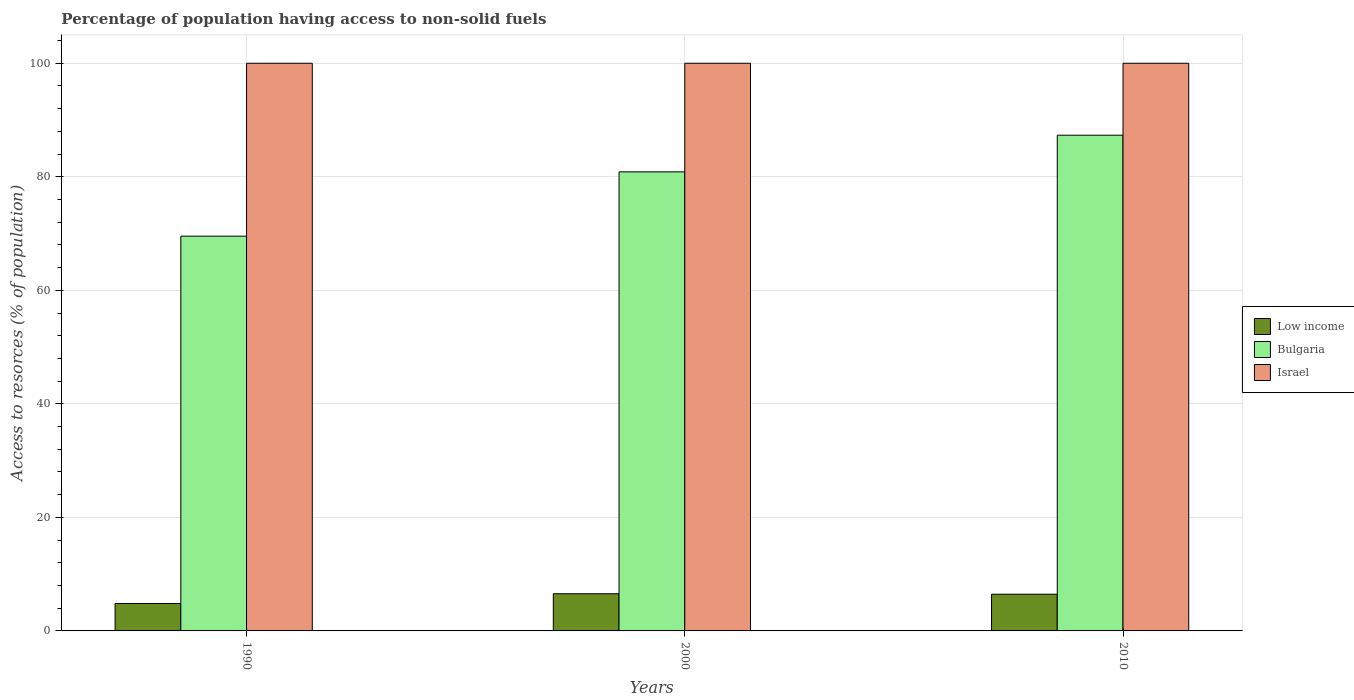How many bars are there on the 2nd tick from the left?
Offer a very short reply. 3. In how many cases, is the number of bars for a given year not equal to the number of legend labels?
Ensure brevity in your answer.  0. What is the percentage of population having access to non-solid fuels in Bulgaria in 2010?
Your answer should be compact. 87.33. Across all years, what is the maximum percentage of population having access to non-solid fuels in Bulgaria?
Provide a short and direct response. 87.33. Across all years, what is the minimum percentage of population having access to non-solid fuels in Bulgaria?
Your answer should be very brief. 69.54. In which year was the percentage of population having access to non-solid fuels in Israel maximum?
Offer a very short reply. 1990. What is the total percentage of population having access to non-solid fuels in Low income in the graph?
Make the answer very short. 17.84. What is the difference between the percentage of population having access to non-solid fuels in Bulgaria in 2000 and that in 2010?
Your answer should be compact. -6.46. What is the difference between the percentage of population having access to non-solid fuels in Israel in 2000 and the percentage of population having access to non-solid fuels in Bulgaria in 1990?
Provide a short and direct response. 30.46. What is the average percentage of population having access to non-solid fuels in Low income per year?
Offer a terse response. 5.95. In the year 2000, what is the difference between the percentage of population having access to non-solid fuels in Israel and percentage of population having access to non-solid fuels in Bulgaria?
Make the answer very short. 19.13. What is the ratio of the percentage of population having access to non-solid fuels in Low income in 1990 to that in 2010?
Offer a very short reply. 0.75. Is the difference between the percentage of population having access to non-solid fuels in Israel in 1990 and 2010 greater than the difference between the percentage of population having access to non-solid fuels in Bulgaria in 1990 and 2010?
Offer a very short reply. Yes. What is the difference between the highest and the second highest percentage of population having access to non-solid fuels in Low income?
Give a very brief answer. 0.09. In how many years, is the percentage of population having access to non-solid fuels in Low income greater than the average percentage of population having access to non-solid fuels in Low income taken over all years?
Ensure brevity in your answer.  2. Is the sum of the percentage of population having access to non-solid fuels in Low income in 1990 and 2000 greater than the maximum percentage of population having access to non-solid fuels in Bulgaria across all years?
Offer a terse response. No. How many bars are there?
Keep it short and to the point. 9. Are all the bars in the graph horizontal?
Offer a terse response. No. How many years are there in the graph?
Provide a short and direct response. 3. Does the graph contain grids?
Give a very brief answer. Yes. How many legend labels are there?
Provide a short and direct response. 3. What is the title of the graph?
Your answer should be compact. Percentage of population having access to non-solid fuels. What is the label or title of the Y-axis?
Your answer should be very brief. Access to resorces (% of population). What is the Access to resorces (% of population) in Low income in 1990?
Ensure brevity in your answer.  4.83. What is the Access to resorces (% of population) of Bulgaria in 1990?
Your answer should be very brief. 69.54. What is the Access to resorces (% of population) in Low income in 2000?
Your answer should be very brief. 6.55. What is the Access to resorces (% of population) in Bulgaria in 2000?
Provide a short and direct response. 80.87. What is the Access to resorces (% of population) of Low income in 2010?
Your answer should be very brief. 6.46. What is the Access to resorces (% of population) of Bulgaria in 2010?
Provide a succinct answer. 87.33. Across all years, what is the maximum Access to resorces (% of population) of Low income?
Keep it short and to the point. 6.55. Across all years, what is the maximum Access to resorces (% of population) of Bulgaria?
Offer a very short reply. 87.33. Across all years, what is the minimum Access to resorces (% of population) of Low income?
Provide a short and direct response. 4.83. Across all years, what is the minimum Access to resorces (% of population) in Bulgaria?
Keep it short and to the point. 69.54. What is the total Access to resorces (% of population) in Low income in the graph?
Keep it short and to the point. 17.84. What is the total Access to resorces (% of population) of Bulgaria in the graph?
Your response must be concise. 237.74. What is the total Access to resorces (% of population) in Israel in the graph?
Offer a terse response. 300. What is the difference between the Access to resorces (% of population) in Low income in 1990 and that in 2000?
Give a very brief answer. -1.72. What is the difference between the Access to resorces (% of population) in Bulgaria in 1990 and that in 2000?
Your answer should be very brief. -11.33. What is the difference between the Access to resorces (% of population) in Low income in 1990 and that in 2010?
Offer a very short reply. -1.64. What is the difference between the Access to resorces (% of population) of Bulgaria in 1990 and that in 2010?
Ensure brevity in your answer.  -17.79. What is the difference between the Access to resorces (% of population) of Low income in 2000 and that in 2010?
Make the answer very short. 0.09. What is the difference between the Access to resorces (% of population) in Bulgaria in 2000 and that in 2010?
Your answer should be compact. -6.46. What is the difference between the Access to resorces (% of population) of Israel in 2000 and that in 2010?
Your answer should be compact. 0. What is the difference between the Access to resorces (% of population) of Low income in 1990 and the Access to resorces (% of population) of Bulgaria in 2000?
Ensure brevity in your answer.  -76.04. What is the difference between the Access to resorces (% of population) in Low income in 1990 and the Access to resorces (% of population) in Israel in 2000?
Your answer should be compact. -95.17. What is the difference between the Access to resorces (% of population) in Bulgaria in 1990 and the Access to resorces (% of population) in Israel in 2000?
Your response must be concise. -30.46. What is the difference between the Access to resorces (% of population) of Low income in 1990 and the Access to resorces (% of population) of Bulgaria in 2010?
Ensure brevity in your answer.  -82.5. What is the difference between the Access to resorces (% of population) of Low income in 1990 and the Access to resorces (% of population) of Israel in 2010?
Provide a succinct answer. -95.17. What is the difference between the Access to resorces (% of population) of Bulgaria in 1990 and the Access to resorces (% of population) of Israel in 2010?
Provide a short and direct response. -30.46. What is the difference between the Access to resorces (% of population) of Low income in 2000 and the Access to resorces (% of population) of Bulgaria in 2010?
Make the answer very short. -80.78. What is the difference between the Access to resorces (% of population) of Low income in 2000 and the Access to resorces (% of population) of Israel in 2010?
Your response must be concise. -93.45. What is the difference between the Access to resorces (% of population) in Bulgaria in 2000 and the Access to resorces (% of population) in Israel in 2010?
Provide a succinct answer. -19.13. What is the average Access to resorces (% of population) of Low income per year?
Your answer should be compact. 5.95. What is the average Access to resorces (% of population) in Bulgaria per year?
Offer a very short reply. 79.25. What is the average Access to resorces (% of population) in Israel per year?
Make the answer very short. 100. In the year 1990, what is the difference between the Access to resorces (% of population) of Low income and Access to resorces (% of population) of Bulgaria?
Provide a succinct answer. -64.71. In the year 1990, what is the difference between the Access to resorces (% of population) of Low income and Access to resorces (% of population) of Israel?
Provide a short and direct response. -95.17. In the year 1990, what is the difference between the Access to resorces (% of population) of Bulgaria and Access to resorces (% of population) of Israel?
Make the answer very short. -30.46. In the year 2000, what is the difference between the Access to resorces (% of population) of Low income and Access to resorces (% of population) of Bulgaria?
Provide a succinct answer. -74.32. In the year 2000, what is the difference between the Access to resorces (% of population) of Low income and Access to resorces (% of population) of Israel?
Offer a very short reply. -93.45. In the year 2000, what is the difference between the Access to resorces (% of population) in Bulgaria and Access to resorces (% of population) in Israel?
Your response must be concise. -19.13. In the year 2010, what is the difference between the Access to resorces (% of population) in Low income and Access to resorces (% of population) in Bulgaria?
Make the answer very short. -80.86. In the year 2010, what is the difference between the Access to resorces (% of population) in Low income and Access to resorces (% of population) in Israel?
Make the answer very short. -93.54. In the year 2010, what is the difference between the Access to resorces (% of population) of Bulgaria and Access to resorces (% of population) of Israel?
Give a very brief answer. -12.67. What is the ratio of the Access to resorces (% of population) in Low income in 1990 to that in 2000?
Give a very brief answer. 0.74. What is the ratio of the Access to resorces (% of population) in Bulgaria in 1990 to that in 2000?
Give a very brief answer. 0.86. What is the ratio of the Access to resorces (% of population) in Low income in 1990 to that in 2010?
Offer a very short reply. 0.75. What is the ratio of the Access to resorces (% of population) in Bulgaria in 1990 to that in 2010?
Provide a short and direct response. 0.8. What is the ratio of the Access to resorces (% of population) in Low income in 2000 to that in 2010?
Your answer should be compact. 1.01. What is the ratio of the Access to resorces (% of population) in Bulgaria in 2000 to that in 2010?
Offer a very short reply. 0.93. What is the difference between the highest and the second highest Access to resorces (% of population) in Low income?
Make the answer very short. 0.09. What is the difference between the highest and the second highest Access to resorces (% of population) in Bulgaria?
Your answer should be very brief. 6.46. What is the difference between the highest and the lowest Access to resorces (% of population) in Low income?
Ensure brevity in your answer.  1.72. What is the difference between the highest and the lowest Access to resorces (% of population) in Bulgaria?
Keep it short and to the point. 17.79. 